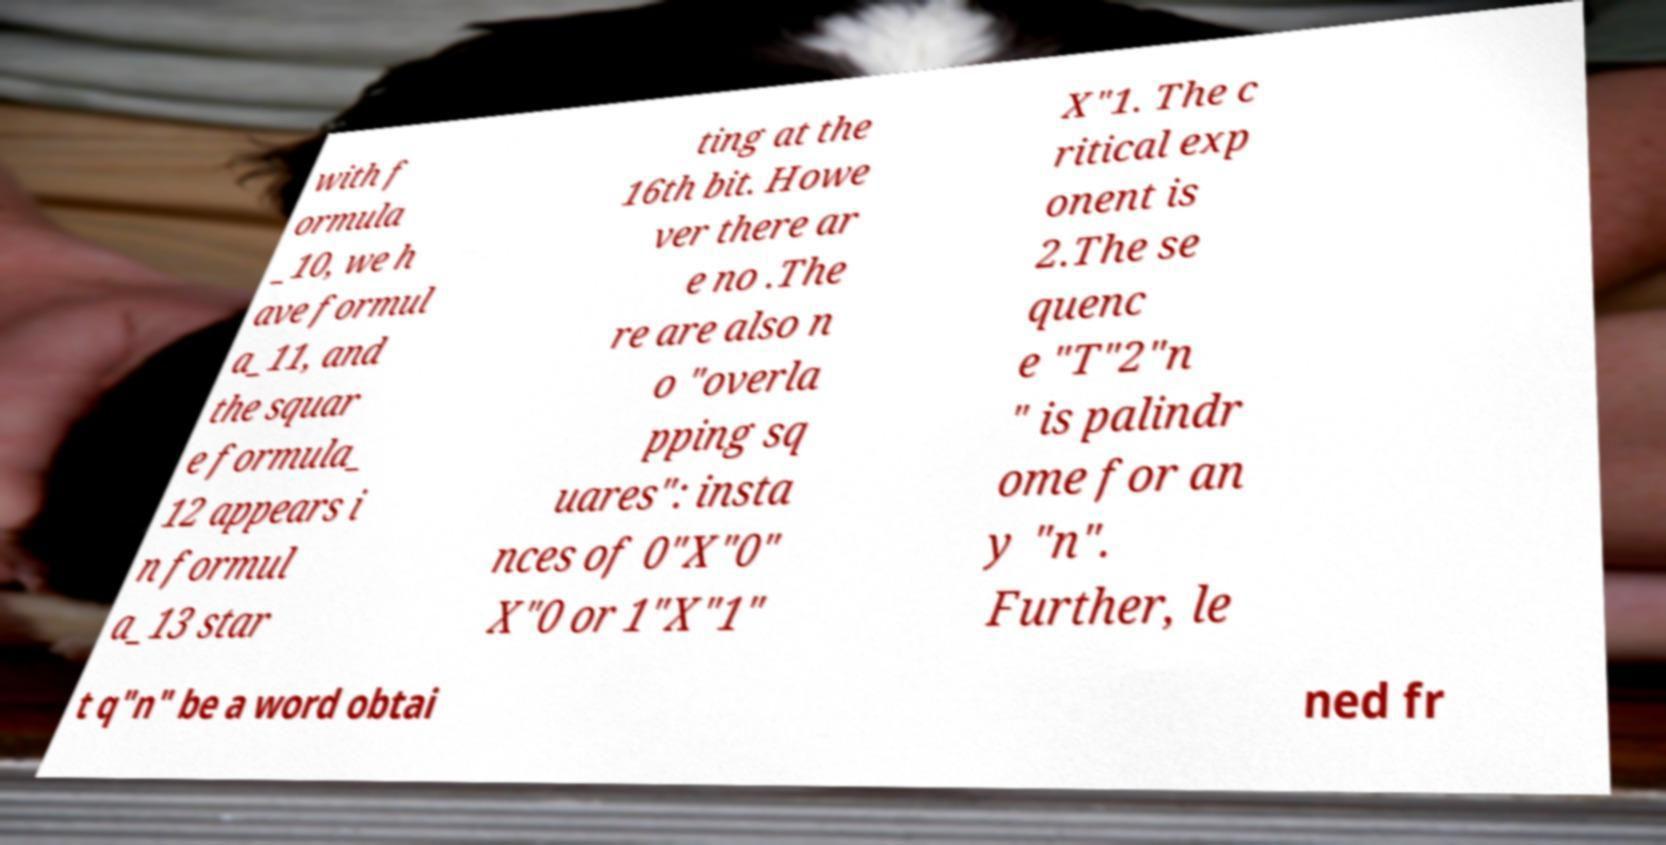For documentation purposes, I need the text within this image transcribed. Could you provide that? with f ormula _10, we h ave formul a_11, and the squar e formula_ 12 appears i n formul a_13 star ting at the 16th bit. Howe ver there ar e no .The re are also n o "overla pping sq uares": insta nces of 0"X"0" X"0 or 1"X"1" X"1. The c ritical exp onent is 2.The se quenc e "T"2"n " is palindr ome for an y "n". Further, le t q"n" be a word obtai ned fr 